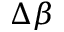<formula> <loc_0><loc_0><loc_500><loc_500>\Delta \beta</formula> 